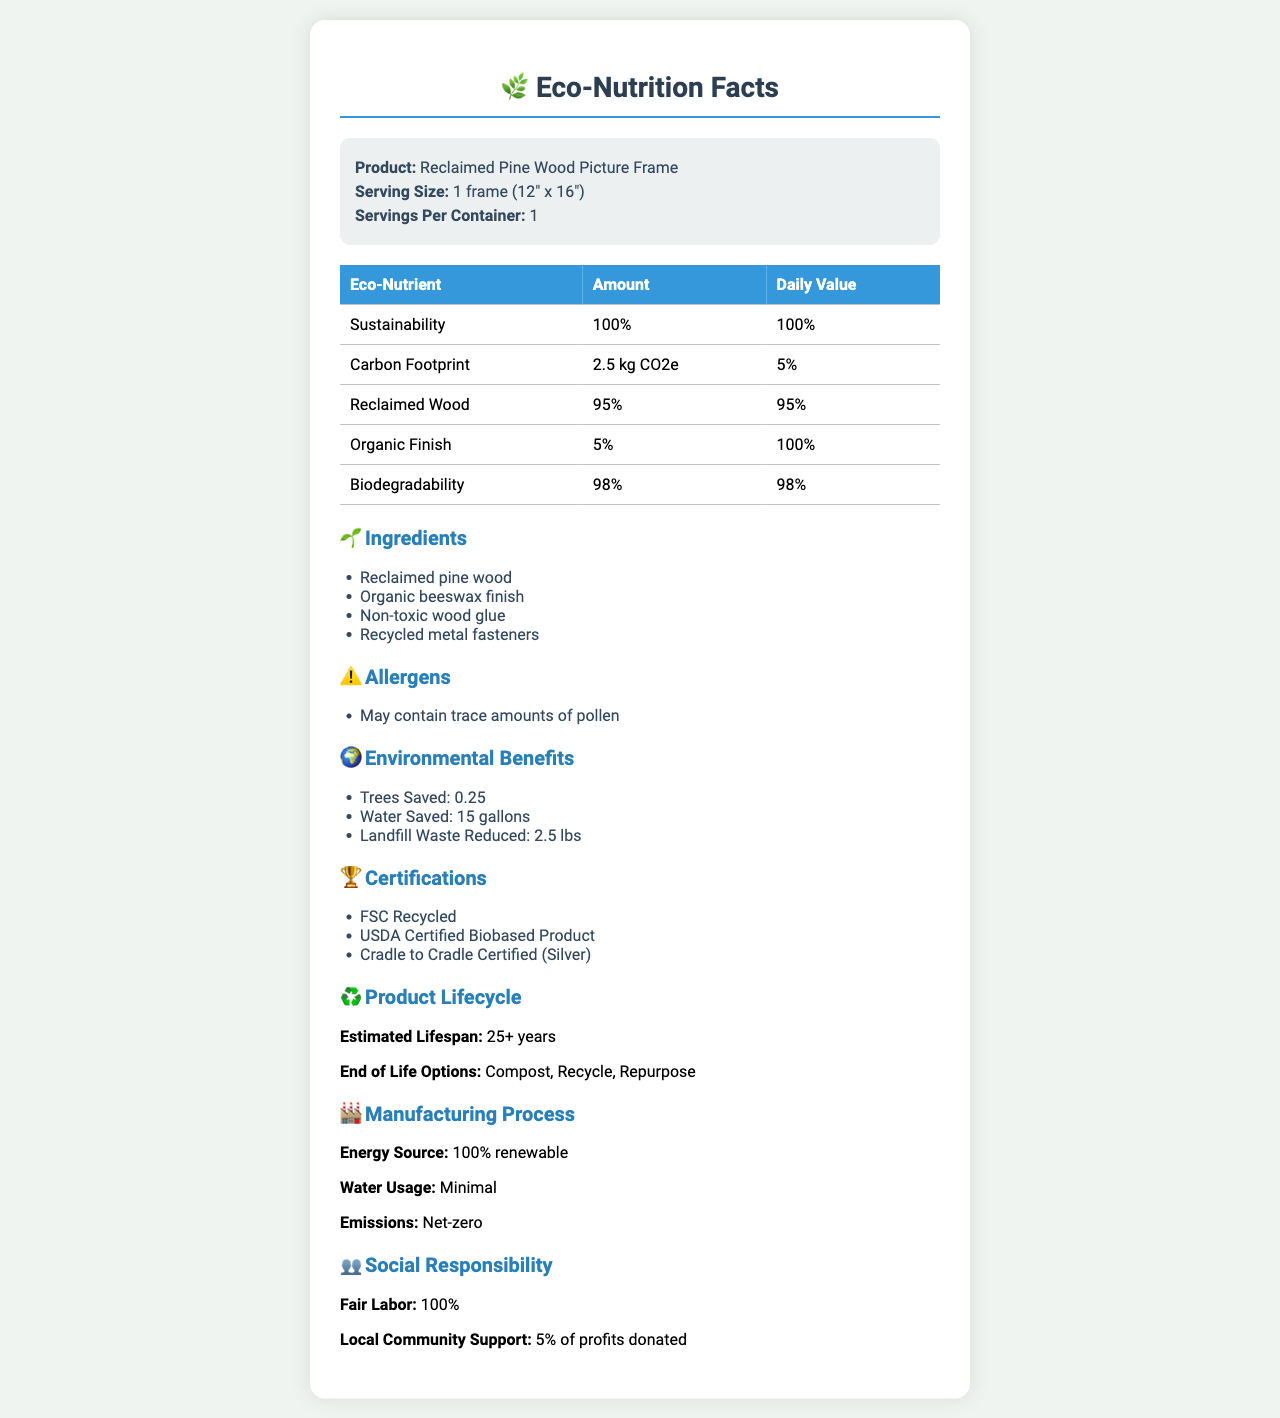what is the product name? The product name is explicitly stated in the document under the product info section.
Answer: Reclaimed Pine Wood Picture Frame what is the serving size for the picture frame? The serving size is mentioned in the product info section of the document.
Answer: 1 frame (12" x 16") how much of the product is made from reclaimed wood? According to the nutritional facts table, reclaimed wood makes up 95% of the product.
Answer: 95% what is the daily value percentage for sustainability? The nutritional facts table lists the daily value percentage for sustainability at 100%.
Answer: 100% which certifications does this product have? The certifications are listed in the certifications section of the document.
Answer: FSC Recycled, USDA Certified Biobased Product, Cradle to Cradle Certified (Silver) what allergens may be present in this product? The allergens section of the document specifies that the product may contain trace amounts of pollen.
Answer: May contain trace amounts of pollen what are the environmental benefits of this product? A. Reduced landfill waste B. Trees saved C. Water saved D. All of the above The environmental benefits section lists all these benefits: Reduced landfill waste, Trees saved, and Water saved.
Answer: D how many gallons of water are saved by using this product? The environmental benefits section indicates that using this product saves 15 gallons of water.
Answer: 15 gallons what are the end-of-life options for this product? A. Compost B. Recycle C. Repurpose D. All of the above The product lifecycle section points out that the end-of-life options include Compost, Recycle, and Repurpose.
Answer: D does the product support local communities? The social responsibility section indicates that 5% of profits are donated to local community support, so the answer is yes.
Answer: Yes how long is the estimated lifespan of the product? The product lifecycle section estimates the product lifespan to be 25+ years.
Answer: 25+ years describe the entire document or the main idea of the document The document is an eco-nutrition label offering insights into various aspects such as materials and processes used, sustainability metrics, benefits, and certifications, promoting its eco-friendly nature.
Answer: It provides a detailed eco-nutrition facts label for a Reclaimed Pine Wood Picture Frame, encompassing sections on nutritional facts, ingredients, allergens, environmental benefits, certifications, product lifecycle, manufacturing process, and social responsibility. what is the daily value percentage of carbon footprint? According to the nutritional facts table, the daily value percentage for carbon footprint is 5%.
Answer: 5% Is the wood glue used in the product toxic? The ingredients section indicates that non-toxic wood glue is used, so the answer is no.
Answer: No how many lbs of landfill waste is reduced by this product? The environmental benefits section states that 2.5 lbs of landfill waste is reduced by using this product.
Answer: 2.5 lbs where does the document mention water usage in the manufacturing process? The manufacturing process section mentions that the water usage is minimal.
Answer: Minimal can this product potentially cause allergic reactions unrelated to the listed allergens? The document only specifies that the product may contain trace amounts of pollen but does not address other potential allergens beyond the listed ones.
Answer: Cannot be determined 